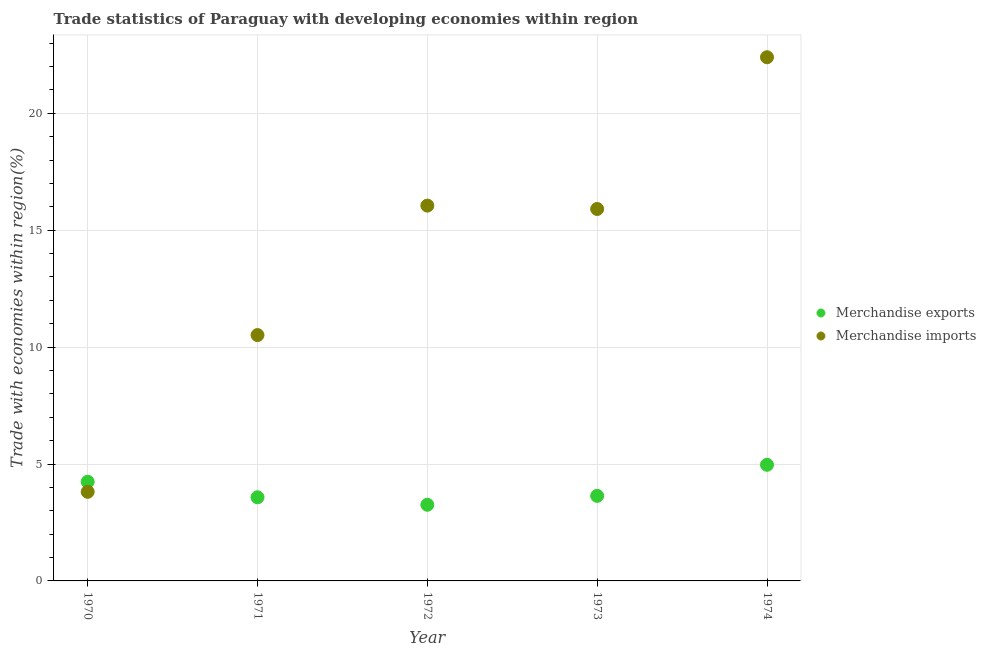How many different coloured dotlines are there?
Make the answer very short. 2. What is the merchandise exports in 1974?
Your answer should be compact. 4.97. Across all years, what is the maximum merchandise exports?
Ensure brevity in your answer.  4.97. Across all years, what is the minimum merchandise exports?
Offer a very short reply. 3.26. In which year was the merchandise imports maximum?
Give a very brief answer. 1974. In which year was the merchandise exports minimum?
Give a very brief answer. 1972. What is the total merchandise exports in the graph?
Provide a succinct answer. 19.68. What is the difference between the merchandise imports in 1971 and that in 1973?
Offer a terse response. -5.39. What is the difference between the merchandise imports in 1972 and the merchandise exports in 1970?
Give a very brief answer. 11.81. What is the average merchandise imports per year?
Provide a short and direct response. 13.74. In the year 1970, what is the difference between the merchandise imports and merchandise exports?
Your response must be concise. -0.43. What is the ratio of the merchandise imports in 1971 to that in 1974?
Make the answer very short. 0.47. Is the merchandise imports in 1972 less than that in 1973?
Keep it short and to the point. No. Is the difference between the merchandise imports in 1973 and 1974 greater than the difference between the merchandise exports in 1973 and 1974?
Ensure brevity in your answer.  No. What is the difference between the highest and the second highest merchandise imports?
Your answer should be very brief. 6.35. What is the difference between the highest and the lowest merchandise imports?
Make the answer very short. 18.59. Does the merchandise imports monotonically increase over the years?
Offer a terse response. No. How many dotlines are there?
Your response must be concise. 2. What is the difference between two consecutive major ticks on the Y-axis?
Provide a succinct answer. 5. Are the values on the major ticks of Y-axis written in scientific E-notation?
Offer a very short reply. No. Does the graph contain any zero values?
Offer a very short reply. No. How many legend labels are there?
Offer a terse response. 2. How are the legend labels stacked?
Keep it short and to the point. Vertical. What is the title of the graph?
Offer a terse response. Trade statistics of Paraguay with developing economies within region. Does "All education staff compensation" appear as one of the legend labels in the graph?
Your answer should be compact. No. What is the label or title of the X-axis?
Your answer should be very brief. Year. What is the label or title of the Y-axis?
Make the answer very short. Trade with economies within region(%). What is the Trade with economies within region(%) in Merchandise exports in 1970?
Your answer should be compact. 4.24. What is the Trade with economies within region(%) in Merchandise imports in 1970?
Provide a succinct answer. 3.81. What is the Trade with economies within region(%) in Merchandise exports in 1971?
Ensure brevity in your answer.  3.58. What is the Trade with economies within region(%) of Merchandise imports in 1971?
Offer a very short reply. 10.52. What is the Trade with economies within region(%) in Merchandise exports in 1972?
Give a very brief answer. 3.26. What is the Trade with economies within region(%) in Merchandise imports in 1972?
Make the answer very short. 16.05. What is the Trade with economies within region(%) of Merchandise exports in 1973?
Make the answer very short. 3.64. What is the Trade with economies within region(%) in Merchandise imports in 1973?
Ensure brevity in your answer.  15.91. What is the Trade with economies within region(%) in Merchandise exports in 1974?
Provide a short and direct response. 4.97. What is the Trade with economies within region(%) in Merchandise imports in 1974?
Your answer should be compact. 22.4. Across all years, what is the maximum Trade with economies within region(%) in Merchandise exports?
Make the answer very short. 4.97. Across all years, what is the maximum Trade with economies within region(%) in Merchandise imports?
Give a very brief answer. 22.4. Across all years, what is the minimum Trade with economies within region(%) of Merchandise exports?
Provide a short and direct response. 3.26. Across all years, what is the minimum Trade with economies within region(%) of Merchandise imports?
Keep it short and to the point. 3.81. What is the total Trade with economies within region(%) in Merchandise exports in the graph?
Offer a very short reply. 19.68. What is the total Trade with economies within region(%) of Merchandise imports in the graph?
Your answer should be very brief. 68.68. What is the difference between the Trade with economies within region(%) in Merchandise exports in 1970 and that in 1971?
Your response must be concise. 0.67. What is the difference between the Trade with economies within region(%) of Merchandise imports in 1970 and that in 1971?
Offer a terse response. -6.7. What is the difference between the Trade with economies within region(%) of Merchandise exports in 1970 and that in 1972?
Give a very brief answer. 0.99. What is the difference between the Trade with economies within region(%) in Merchandise imports in 1970 and that in 1972?
Ensure brevity in your answer.  -12.24. What is the difference between the Trade with economies within region(%) of Merchandise exports in 1970 and that in 1973?
Give a very brief answer. 0.6. What is the difference between the Trade with economies within region(%) of Merchandise imports in 1970 and that in 1973?
Give a very brief answer. -12.1. What is the difference between the Trade with economies within region(%) of Merchandise exports in 1970 and that in 1974?
Give a very brief answer. -0.72. What is the difference between the Trade with economies within region(%) of Merchandise imports in 1970 and that in 1974?
Ensure brevity in your answer.  -18.59. What is the difference between the Trade with economies within region(%) of Merchandise exports in 1971 and that in 1972?
Provide a succinct answer. 0.32. What is the difference between the Trade with economies within region(%) in Merchandise imports in 1971 and that in 1972?
Your response must be concise. -5.54. What is the difference between the Trade with economies within region(%) of Merchandise exports in 1971 and that in 1973?
Offer a terse response. -0.06. What is the difference between the Trade with economies within region(%) of Merchandise imports in 1971 and that in 1973?
Provide a short and direct response. -5.39. What is the difference between the Trade with economies within region(%) of Merchandise exports in 1971 and that in 1974?
Provide a succinct answer. -1.39. What is the difference between the Trade with economies within region(%) of Merchandise imports in 1971 and that in 1974?
Your answer should be compact. -11.88. What is the difference between the Trade with economies within region(%) in Merchandise exports in 1972 and that in 1973?
Ensure brevity in your answer.  -0.38. What is the difference between the Trade with economies within region(%) of Merchandise imports in 1972 and that in 1973?
Give a very brief answer. 0.14. What is the difference between the Trade with economies within region(%) of Merchandise exports in 1972 and that in 1974?
Your response must be concise. -1.71. What is the difference between the Trade with economies within region(%) in Merchandise imports in 1972 and that in 1974?
Keep it short and to the point. -6.35. What is the difference between the Trade with economies within region(%) in Merchandise exports in 1973 and that in 1974?
Your answer should be very brief. -1.33. What is the difference between the Trade with economies within region(%) in Merchandise imports in 1973 and that in 1974?
Your answer should be compact. -6.49. What is the difference between the Trade with economies within region(%) in Merchandise exports in 1970 and the Trade with economies within region(%) in Merchandise imports in 1971?
Offer a terse response. -6.27. What is the difference between the Trade with economies within region(%) in Merchandise exports in 1970 and the Trade with economies within region(%) in Merchandise imports in 1972?
Offer a terse response. -11.81. What is the difference between the Trade with economies within region(%) of Merchandise exports in 1970 and the Trade with economies within region(%) of Merchandise imports in 1973?
Ensure brevity in your answer.  -11.67. What is the difference between the Trade with economies within region(%) in Merchandise exports in 1970 and the Trade with economies within region(%) in Merchandise imports in 1974?
Your response must be concise. -18.16. What is the difference between the Trade with economies within region(%) in Merchandise exports in 1971 and the Trade with economies within region(%) in Merchandise imports in 1972?
Your answer should be compact. -12.48. What is the difference between the Trade with economies within region(%) of Merchandise exports in 1971 and the Trade with economies within region(%) of Merchandise imports in 1973?
Make the answer very short. -12.33. What is the difference between the Trade with economies within region(%) in Merchandise exports in 1971 and the Trade with economies within region(%) in Merchandise imports in 1974?
Provide a short and direct response. -18.82. What is the difference between the Trade with economies within region(%) of Merchandise exports in 1972 and the Trade with economies within region(%) of Merchandise imports in 1973?
Give a very brief answer. -12.65. What is the difference between the Trade with economies within region(%) of Merchandise exports in 1972 and the Trade with economies within region(%) of Merchandise imports in 1974?
Your answer should be compact. -19.14. What is the difference between the Trade with economies within region(%) of Merchandise exports in 1973 and the Trade with economies within region(%) of Merchandise imports in 1974?
Offer a terse response. -18.76. What is the average Trade with economies within region(%) in Merchandise exports per year?
Give a very brief answer. 3.94. What is the average Trade with economies within region(%) in Merchandise imports per year?
Your response must be concise. 13.74. In the year 1970, what is the difference between the Trade with economies within region(%) in Merchandise exports and Trade with economies within region(%) in Merchandise imports?
Offer a very short reply. 0.43. In the year 1971, what is the difference between the Trade with economies within region(%) of Merchandise exports and Trade with economies within region(%) of Merchandise imports?
Make the answer very short. -6.94. In the year 1972, what is the difference between the Trade with economies within region(%) in Merchandise exports and Trade with economies within region(%) in Merchandise imports?
Offer a terse response. -12.8. In the year 1973, what is the difference between the Trade with economies within region(%) in Merchandise exports and Trade with economies within region(%) in Merchandise imports?
Make the answer very short. -12.27. In the year 1974, what is the difference between the Trade with economies within region(%) of Merchandise exports and Trade with economies within region(%) of Merchandise imports?
Provide a short and direct response. -17.43. What is the ratio of the Trade with economies within region(%) of Merchandise exports in 1970 to that in 1971?
Offer a very short reply. 1.19. What is the ratio of the Trade with economies within region(%) of Merchandise imports in 1970 to that in 1971?
Offer a very short reply. 0.36. What is the ratio of the Trade with economies within region(%) in Merchandise exports in 1970 to that in 1972?
Make the answer very short. 1.3. What is the ratio of the Trade with economies within region(%) of Merchandise imports in 1970 to that in 1972?
Give a very brief answer. 0.24. What is the ratio of the Trade with economies within region(%) in Merchandise exports in 1970 to that in 1973?
Your answer should be compact. 1.17. What is the ratio of the Trade with economies within region(%) in Merchandise imports in 1970 to that in 1973?
Your answer should be compact. 0.24. What is the ratio of the Trade with economies within region(%) in Merchandise exports in 1970 to that in 1974?
Offer a very short reply. 0.85. What is the ratio of the Trade with economies within region(%) of Merchandise imports in 1970 to that in 1974?
Your answer should be very brief. 0.17. What is the ratio of the Trade with economies within region(%) of Merchandise exports in 1971 to that in 1972?
Provide a short and direct response. 1.1. What is the ratio of the Trade with economies within region(%) of Merchandise imports in 1971 to that in 1972?
Offer a terse response. 0.66. What is the ratio of the Trade with economies within region(%) in Merchandise exports in 1971 to that in 1973?
Offer a very short reply. 0.98. What is the ratio of the Trade with economies within region(%) of Merchandise imports in 1971 to that in 1973?
Offer a terse response. 0.66. What is the ratio of the Trade with economies within region(%) in Merchandise exports in 1971 to that in 1974?
Ensure brevity in your answer.  0.72. What is the ratio of the Trade with economies within region(%) in Merchandise imports in 1971 to that in 1974?
Your answer should be very brief. 0.47. What is the ratio of the Trade with economies within region(%) in Merchandise exports in 1972 to that in 1973?
Your response must be concise. 0.9. What is the ratio of the Trade with economies within region(%) of Merchandise imports in 1972 to that in 1973?
Ensure brevity in your answer.  1.01. What is the ratio of the Trade with economies within region(%) of Merchandise exports in 1972 to that in 1974?
Offer a very short reply. 0.66. What is the ratio of the Trade with economies within region(%) of Merchandise imports in 1972 to that in 1974?
Offer a terse response. 0.72. What is the ratio of the Trade with economies within region(%) in Merchandise exports in 1973 to that in 1974?
Offer a terse response. 0.73. What is the ratio of the Trade with economies within region(%) of Merchandise imports in 1973 to that in 1974?
Your response must be concise. 0.71. What is the difference between the highest and the second highest Trade with economies within region(%) of Merchandise exports?
Provide a succinct answer. 0.72. What is the difference between the highest and the second highest Trade with economies within region(%) of Merchandise imports?
Make the answer very short. 6.35. What is the difference between the highest and the lowest Trade with economies within region(%) in Merchandise exports?
Keep it short and to the point. 1.71. What is the difference between the highest and the lowest Trade with economies within region(%) in Merchandise imports?
Keep it short and to the point. 18.59. 